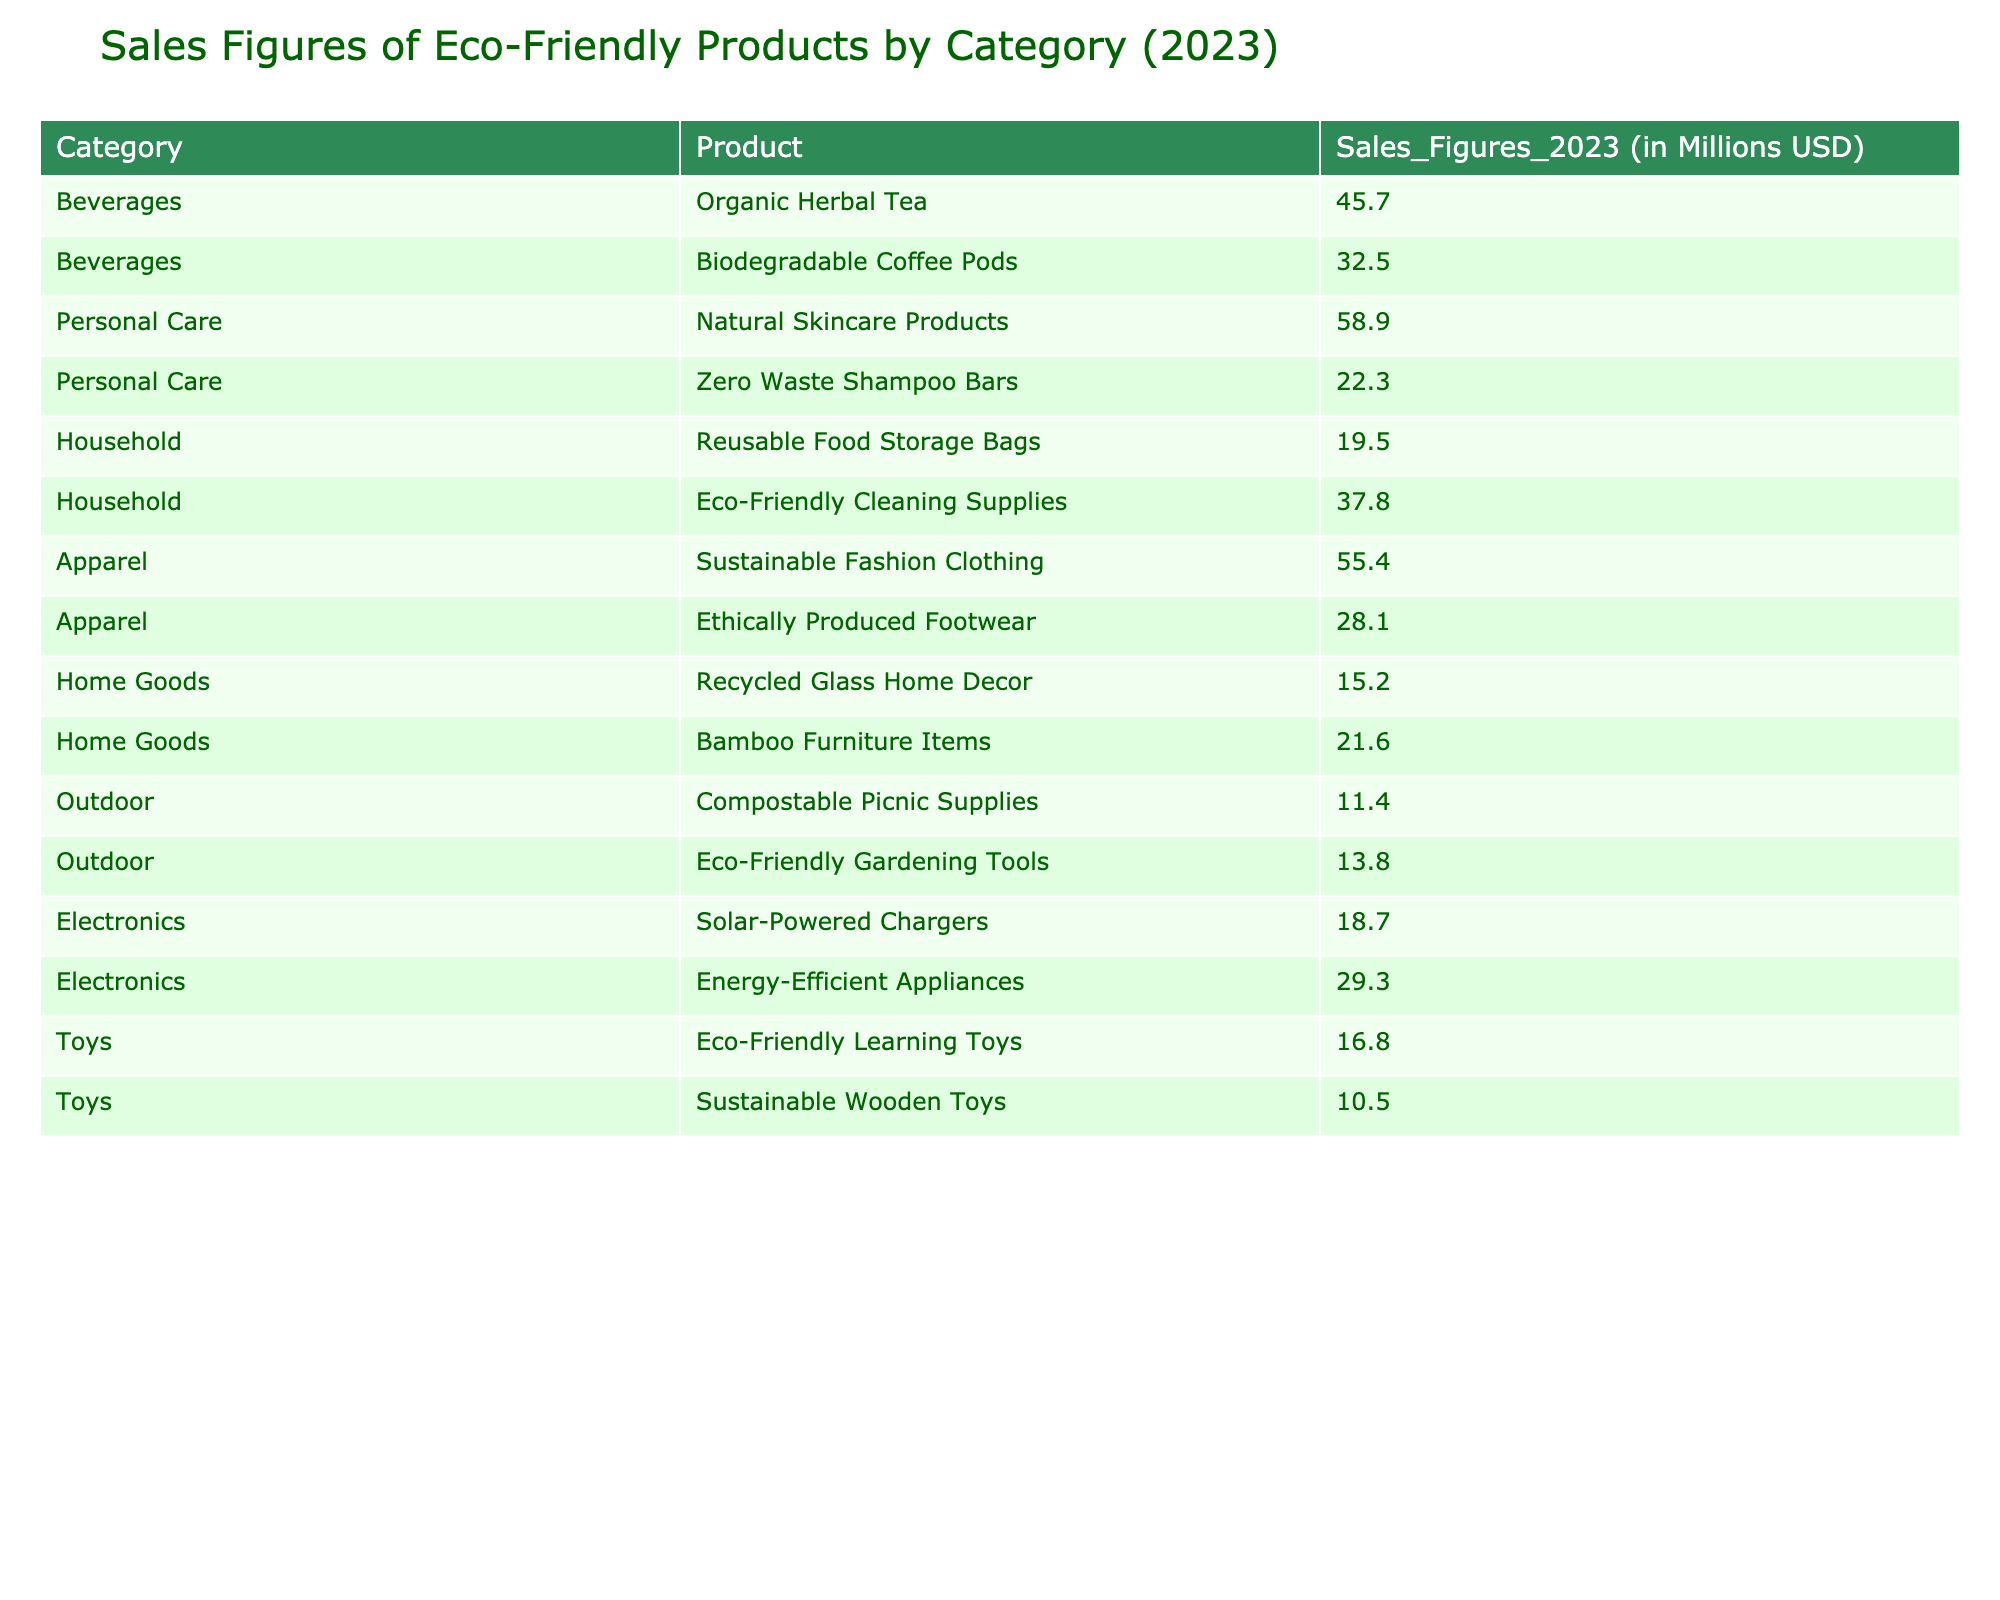What are the total sales figures for the Apparel category? The table lists two products under the Apparel category: Sustainable Fashion Clothing with sales figures of 55.4 million USD and Ethically Produced Footwear with sales figures of 28.1 million USD. Adding these figures gives 55.4 + 28.1 = 83.5 million USD.
Answer: 83.5 million USD Which product in the Personal Care category has the lowest sales figures? The table indicates two products in Personal Care: Natural Skincare Products with sales figures of 58.9 million USD and Zero Waste Shampoo Bars with sales figures of 22.3 million USD. The lower value is 22.3 million USD for Zero Waste Shampoo Bars.
Answer: Zero Waste Shampoo Bars Are the sales figures for Eco-Friendly Gardening Tools greater than or equal to the sales figures for Compostable Picnic Supplies? The sales figures for Eco-Friendly Gardening Tools are 13.8 million USD, and for Compostable Picnic Supplies, they are 11.4 million USD. Since 13.8 is greater than 11.4, the statement is true.
Answer: Yes What is the average sales figure of the Household category products? The Household category includes two products: Reusable Food Storage Bags (19.5 million USD) and Eco-Friendly Cleaning Supplies (37.8 million USD). To find the average, we sum these products (19.5 + 37.8 = 57.3 million USD) and divide by the number of products (2). Therefore, the average is 57.3 / 2 = 28.65 million USD.
Answer: 28.65 million USD Which category has the highest total sales figures and what is that total? To determine the highest category, I need to sum the sales figures for each category using the table data. Apparel has a total of 83.5 million USD, Personal Care has 81.2 million USD, Beverages has 78.2 million USD, Household totals 57.3 million USD, Electronics sums to 48 million USD, Toys totals 27.3 million USD, Outdoor totals 25.2 million USD, and Home Goods sums to 36.8 million USD. The highest total is for Apparel with 83.5 million USD.
Answer: Apparel, 83.5 million USD How much more do sales figures of Sustainable Fashion Clothing exceed those of Eco-Friendly Gardening Tools? The sales figures for Sustainable Fashion Clothing are 55.4 million USD and for Eco-Friendly Gardening Tools, they are 13.8 million USD. To find the difference, I subtract the sales figures of Eco-Friendly Gardening Tools from those of Sustainable Fashion Clothing: 55.4 - 13.8 = 41.6 million USD.
Answer: 41.6 million USD 